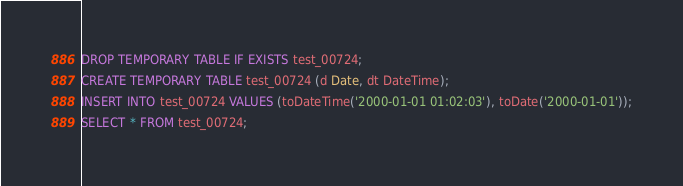<code> <loc_0><loc_0><loc_500><loc_500><_SQL_>DROP TEMPORARY TABLE IF EXISTS test_00724;
CREATE TEMPORARY TABLE test_00724 (d Date, dt DateTime);
INSERT INTO test_00724 VALUES (toDateTime('2000-01-01 01:02:03'), toDate('2000-01-01'));
SELECT * FROM test_00724;
</code> 